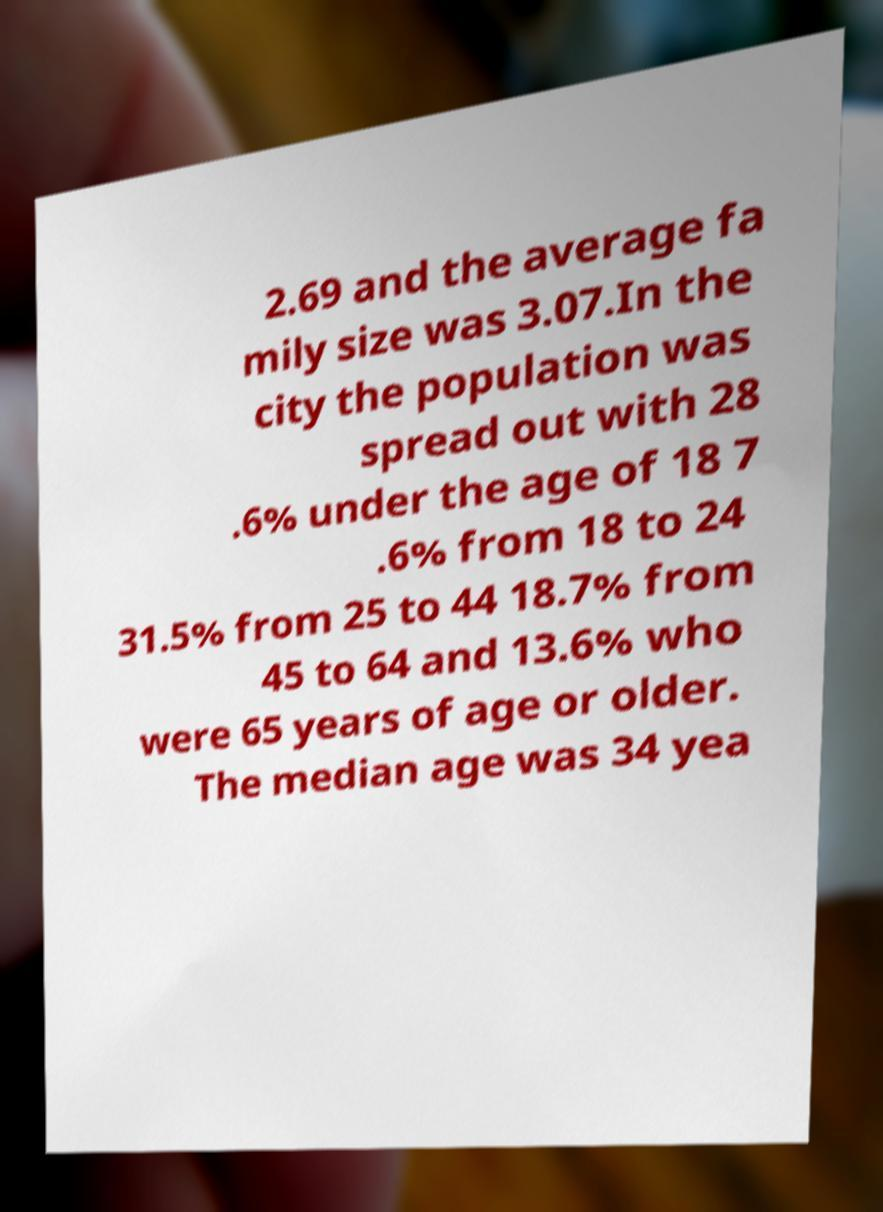Could you assist in decoding the text presented in this image and type it out clearly? 2.69 and the average fa mily size was 3.07.In the city the population was spread out with 28 .6% under the age of 18 7 .6% from 18 to 24 31.5% from 25 to 44 18.7% from 45 to 64 and 13.6% who were 65 years of age or older. The median age was 34 yea 